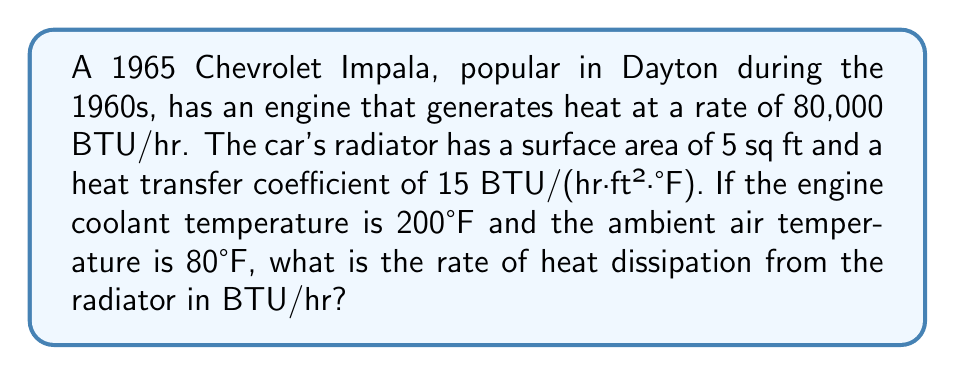Can you answer this question? To solve this problem, we'll use Newton's Law of Cooling:

$$ Q = hA(T_s - T_\infty) $$

Where:
$Q$ = rate of heat transfer (BTU/hr)
$h$ = heat transfer coefficient (BTU/(hr·ft²·°F))
$A$ = surface area (ft²)
$T_s$ = surface temperature (°F)
$T_\infty$ = ambient temperature (°F)

Given:
$h = 15$ BTU/(hr·ft²·°F)
$A = 5$ ft²
$T_s = 200°F$ (assuming coolant temperature equals radiator surface temperature)
$T_\infty = 80°F$

Step 1: Substitute the values into the equation:

$$ Q = 15 \cdot 5 \cdot (200 - 80) $$

Step 2: Simplify:

$$ Q = 15 \cdot 5 \cdot 120 $$
$$ Q = 75 \cdot 120 $$
$$ Q = 9,000 \text{ BTU/hr} $$

Therefore, the rate of heat dissipation from the radiator is 9,000 BTU/hr.
Answer: 9,000 BTU/hr 